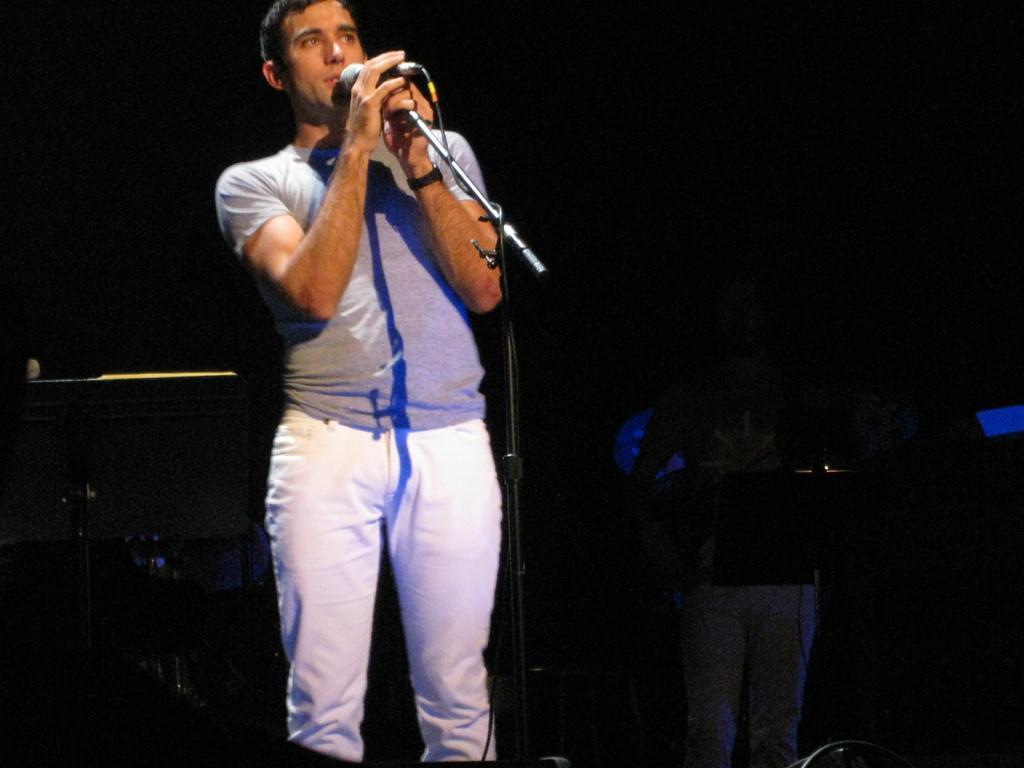Could you give a brief overview of what you see in this image? In this image, there is a person wearing clothes and standing in front of this mic. This person is holding a mic with his hands. There is an another person on the right of the image. 